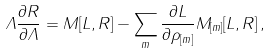Convert formula to latex. <formula><loc_0><loc_0><loc_500><loc_500>\Lambda \frac { \partial R } { \partial \Lambda } = M [ L , R ] - \sum _ { m } \frac { \partial L } { \partial \rho _ { [ m ] } } M _ { [ m ] } [ L , R ] \, ,</formula> 